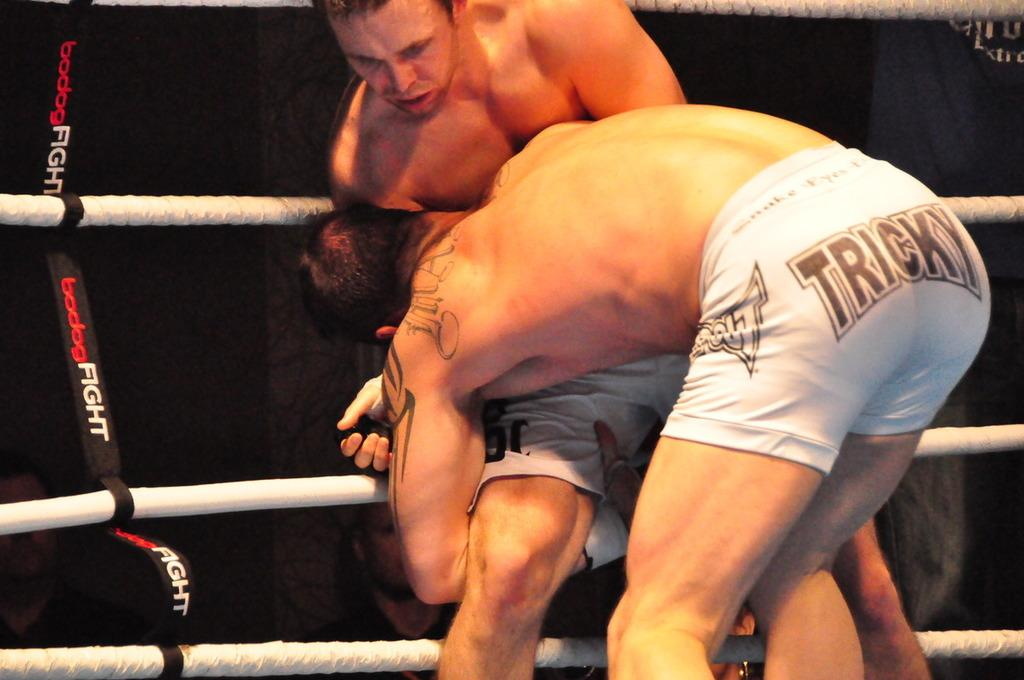Provide a one-sentence caption for the provided image. A man in a wrestling competition has the word "tricky" on his shorts. 